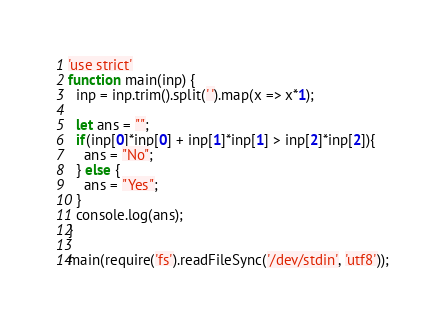<code> <loc_0><loc_0><loc_500><loc_500><_JavaScript_>'use strict'
function main(inp) {
  inp = inp.trim().split(' ').map(x => x*1);
  
  let ans = "";
  if(inp[0]*inp[0] + inp[1]*inp[1] > inp[2]*inp[2]){
	ans = "No";
  } else {
	ans = "Yes";
  }
  console.log(ans);
}

main(require('fs').readFileSync('/dev/stdin', 'utf8'));
</code> 